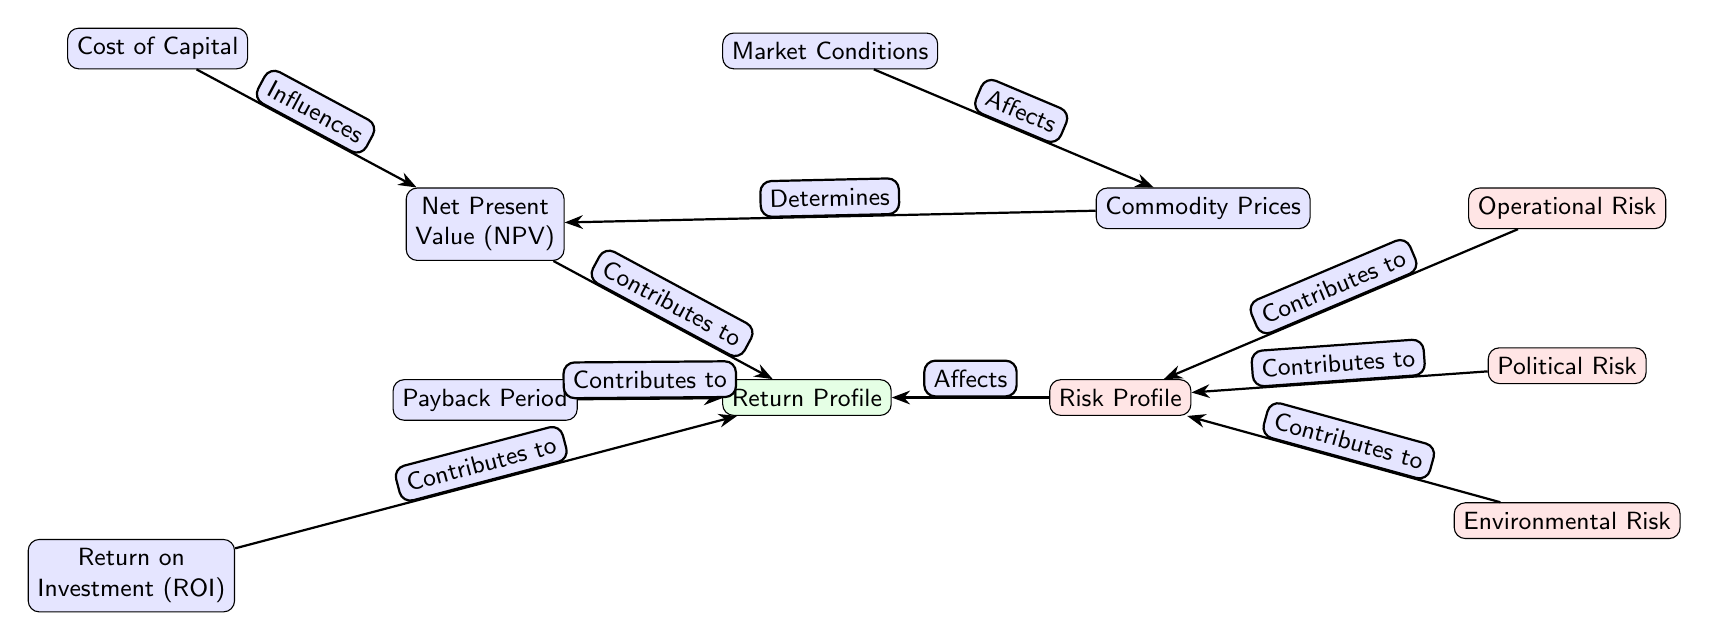What are the three types of risk highlighted in the diagram? The diagram lists three types of risks affecting mining investments: Operational Risk, Political Risk, and Environmental Risk, which can be identified by looking at the risk nodes.
Answer: Operational Risk, Political Risk, Environmental Risk Which node directly influences the Net Present Value (NPV)? The Cost of Capital node is shown to influence the NPV node, which can be seen in the edge labeled "Influences" between these two nodes.
Answer: Cost of Capital How many nodes contribute to the Return Profile? The diagram illustrates three nodes (NPV, Payback Period, and ROI) that contribute to the Return Profile, which can be determined by counting the edges pointing towards the Return Profile node.
Answer: Three What does the Risk Profile affect according to the diagram? According to the diagram, the Risk Profile affects the Return Profile node, as shown by the edge labeled "Affects."
Answer: Return Profile Which external factor is said to affect Commodity Prices? Market Conditions directly affect Commodity Prices, as indicated in the diagram by the arrow labeled "Affects" connecting these two nodes.
Answer: Market Conditions What node contributes to both Return Profile and Risk Profile? The Net Present Value (NPV) contributes to the Return Profile and its influence can be traced through the arrows connecting it. There is no other node implicated by an edge towards both profiles.
Answer: Net Present Value How many total edges are present in the diagram? By counting the connections shown in the diagram, we find that there are seven edges connecting various nodes.
Answer: Seven Which component determines the Net Present Value (NPV)? Commodity Prices directly determine the NPV, as indicated by the edge labeled "Determines" connecting these two nodes in the diagram.
Answer: Commodity Prices What kind of diagram is this representing? The diagram represents a Multi-attribute Decision Analysis Chart specifically for Financial Risk and Return Profiles of Mining Investments, indicated by its structure and context.
Answer: Multi-attribute Decision Analysis Chart 